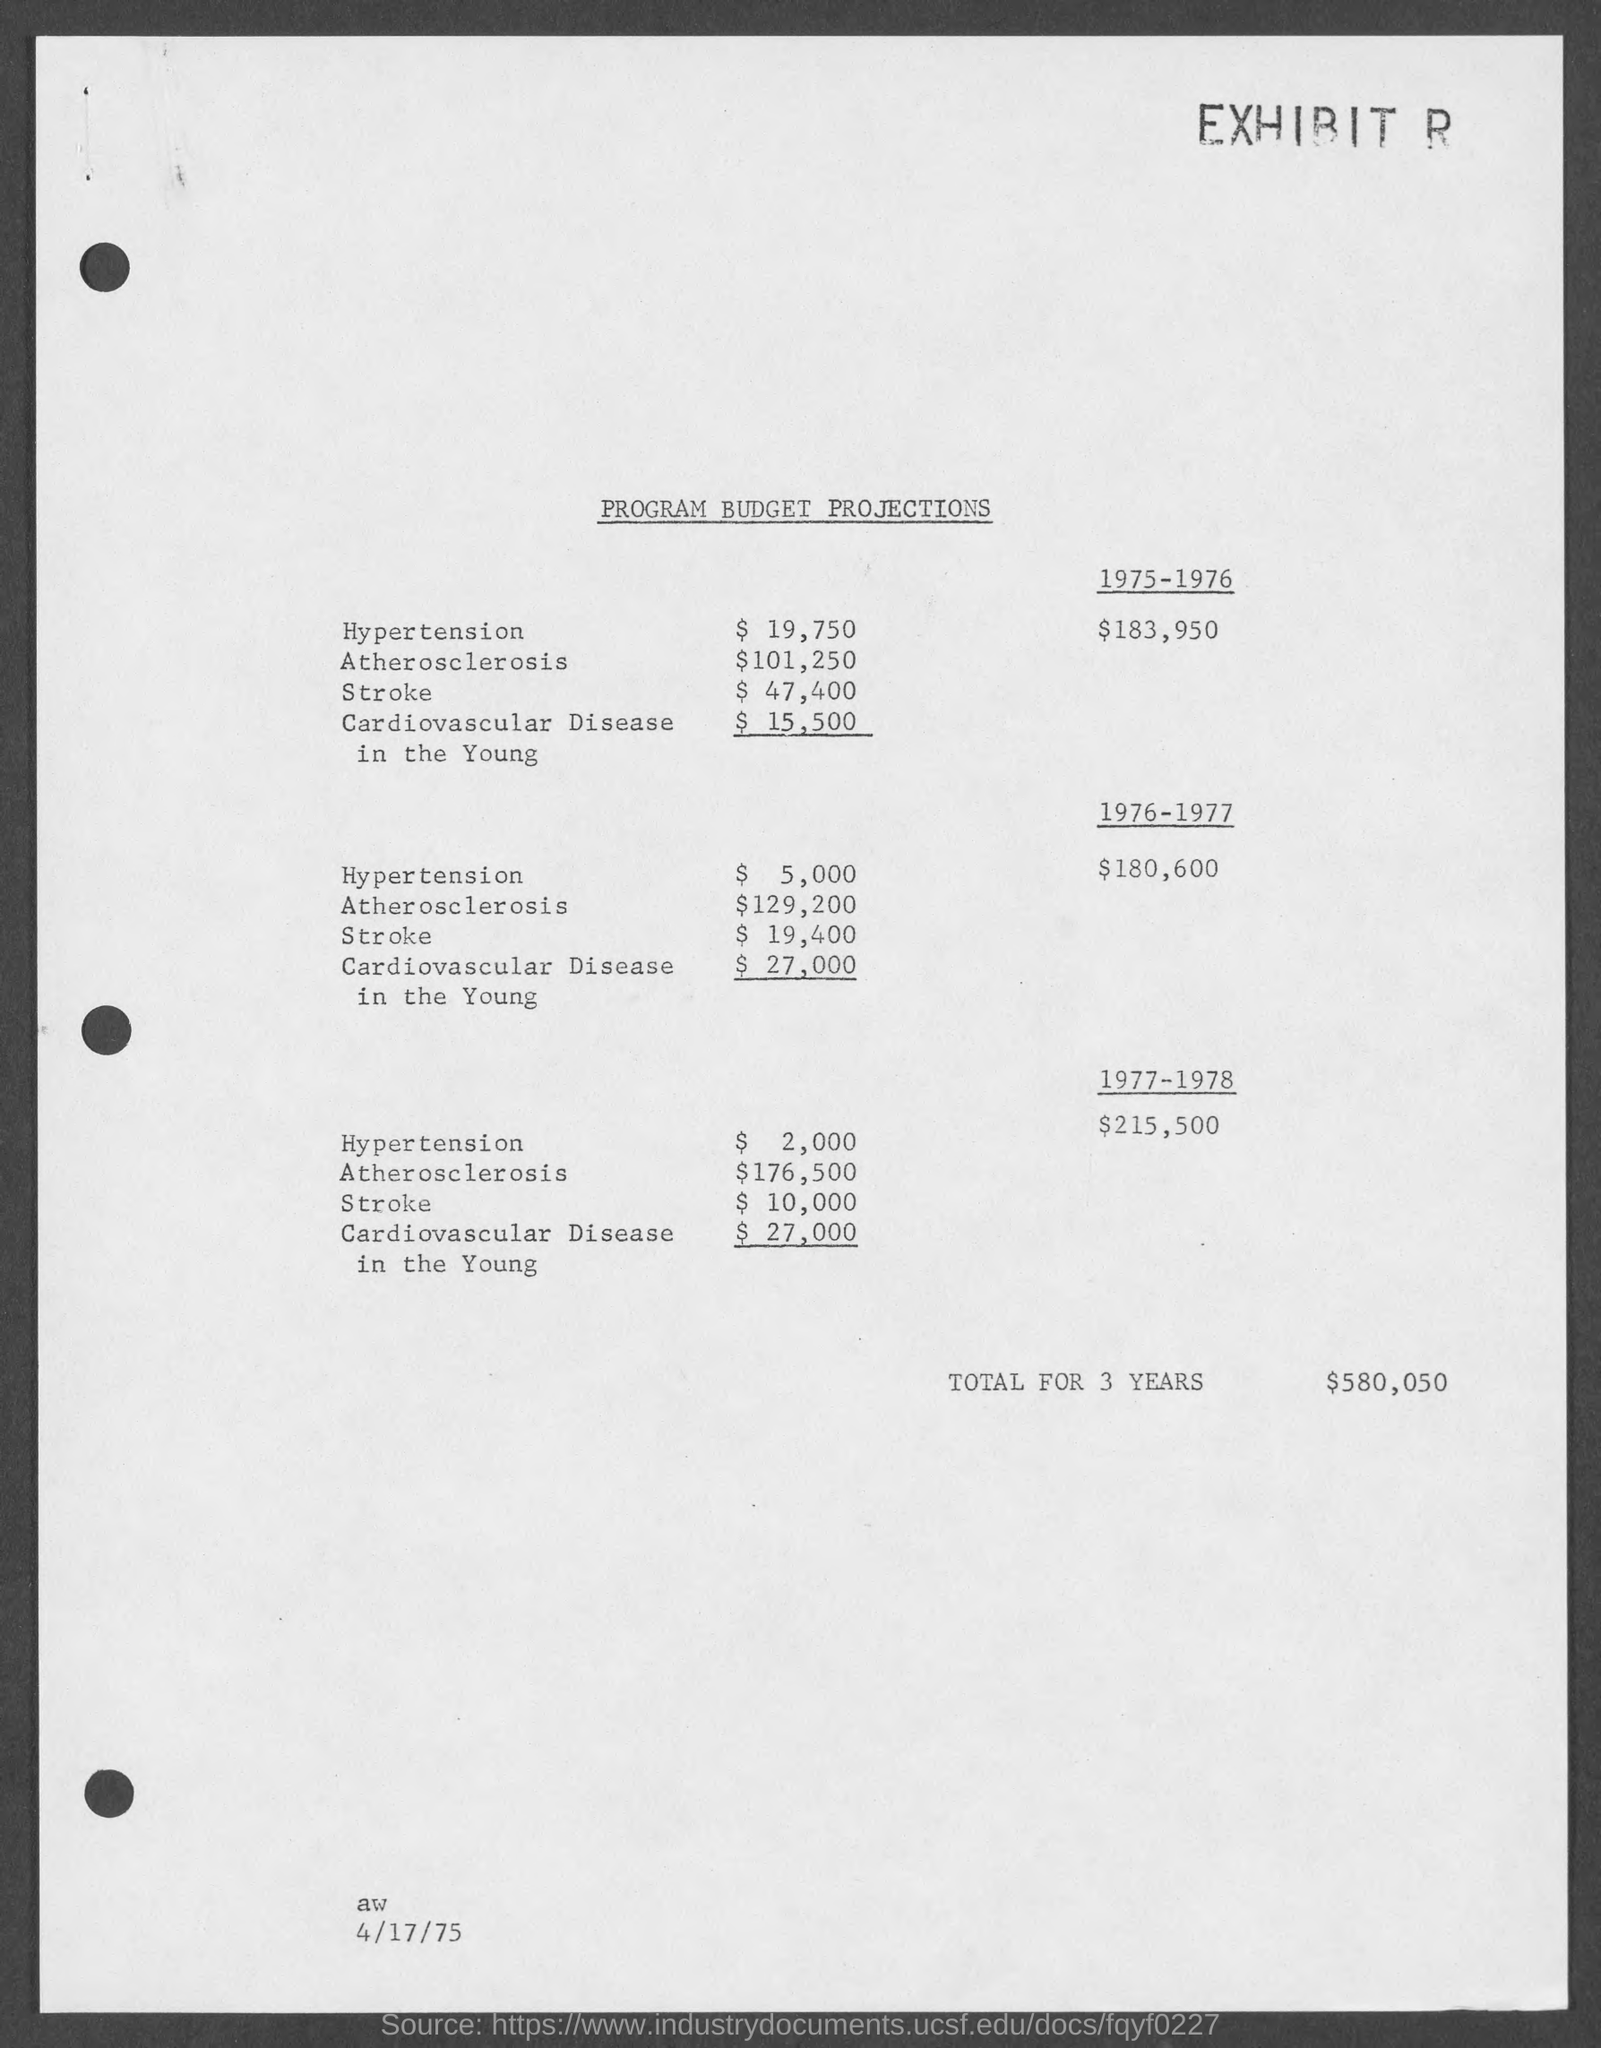Specify some key components in this picture. The document is dated April 17, 1975. The document title is a program budget projections. The total for 3 years is $580,050. 